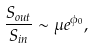<formula> <loc_0><loc_0><loc_500><loc_500>\frac { S _ { o u t } } { S _ { i n } } \sim \mu e ^ { \phi _ { 0 } } ,</formula> 